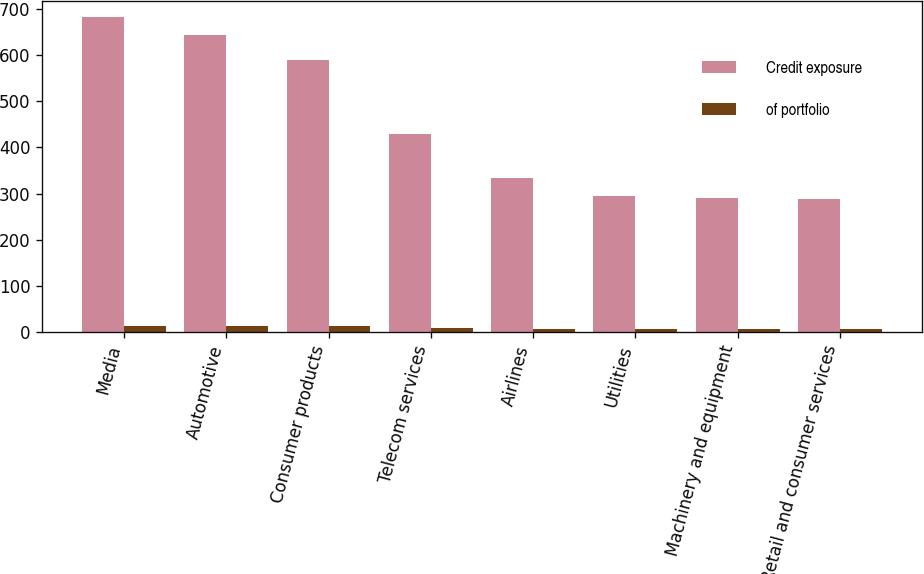Convert chart. <chart><loc_0><loc_0><loc_500><loc_500><stacked_bar_chart><ecel><fcel>Media<fcel>Automotive<fcel>Consumer products<fcel>Telecom services<fcel>Airlines<fcel>Utilities<fcel>Machinery and equipment<fcel>Retail and consumer services<nl><fcel>Credit exposure<fcel>684<fcel>643<fcel>590<fcel>430<fcel>333<fcel>295<fcel>290<fcel>288<nl><fcel>of portfolio<fcel>13.2<fcel>12.4<fcel>11.4<fcel>8.3<fcel>6.5<fcel>5.7<fcel>5.6<fcel>5.6<nl></chart> 